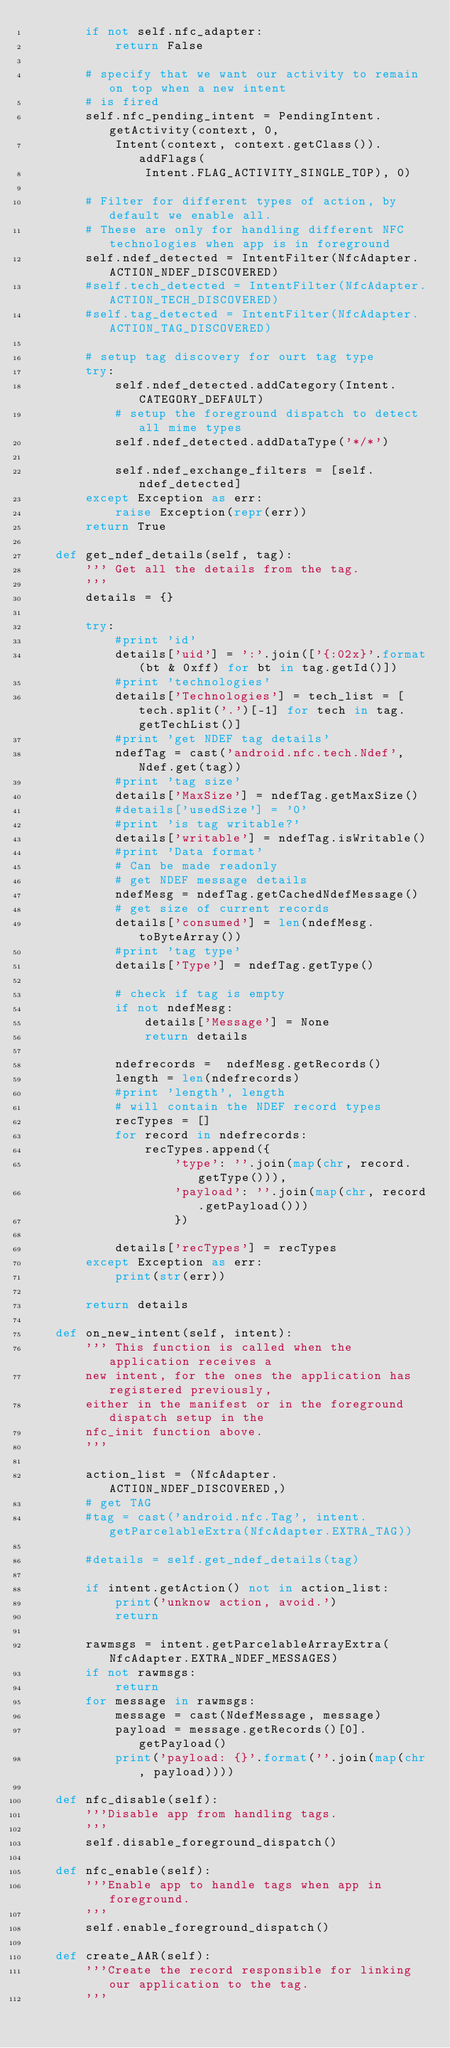<code> <loc_0><loc_0><loc_500><loc_500><_Python_>        if not self.nfc_adapter:
            return False
        
        # specify that we want our activity to remain on top when a new intent
        # is fired
        self.nfc_pending_intent = PendingIntent.getActivity(context, 0,
            Intent(context, context.getClass()).addFlags(
                Intent.FLAG_ACTIVITY_SINGLE_TOP), 0)

        # Filter for different types of action, by default we enable all.
        # These are only for handling different NFC technologies when app is in foreground
        self.ndef_detected = IntentFilter(NfcAdapter.ACTION_NDEF_DISCOVERED)
        #self.tech_detected = IntentFilter(NfcAdapter.ACTION_TECH_DISCOVERED)
        #self.tag_detected = IntentFilter(NfcAdapter.ACTION_TAG_DISCOVERED)

        # setup tag discovery for ourt tag type
        try:
            self.ndef_detected.addCategory(Intent.CATEGORY_DEFAULT)
            # setup the foreground dispatch to detect all mime types
            self.ndef_detected.addDataType('*/*')

            self.ndef_exchange_filters = [self.ndef_detected]
        except Exception as err:
            raise Exception(repr(err))
        return True

    def get_ndef_details(self, tag):
        ''' Get all the details from the tag.
        '''
        details = {}

        try:
            #print 'id'
            details['uid'] = ':'.join(['{:02x}'.format(bt & 0xff) for bt in tag.getId()])
            #print 'technologies'
            details['Technologies'] = tech_list = [tech.split('.')[-1] for tech in tag.getTechList()]
            #print 'get NDEF tag details'
            ndefTag = cast('android.nfc.tech.Ndef', Ndef.get(tag))
            #print 'tag size'
            details['MaxSize'] = ndefTag.getMaxSize()
            #details['usedSize'] = '0'
            #print 'is tag writable?'
            details['writable'] = ndefTag.isWritable()
            #print 'Data format'
            # Can be made readonly
            # get NDEF message details
            ndefMesg = ndefTag.getCachedNdefMessage()
            # get size of current records
            details['consumed'] = len(ndefMesg.toByteArray())
            #print 'tag type'
            details['Type'] = ndefTag.getType()

            # check if tag is empty
            if not ndefMesg:
                details['Message'] = None
                return details

            ndefrecords =  ndefMesg.getRecords()
            length = len(ndefrecords)
            #print 'length', length
            # will contain the NDEF record types
            recTypes = []
            for record in ndefrecords:
                recTypes.append({
                    'type': ''.join(map(chr, record.getType())),
                    'payload': ''.join(map(chr, record.getPayload()))
                    })

            details['recTypes'] = recTypes
        except Exception as err:
            print(str(err))

        return details

    def on_new_intent(self, intent):
        ''' This function is called when the application receives a
        new intent, for the ones the application has registered previously,
        either in the manifest or in the foreground dispatch setup in the
        nfc_init function above. 
        '''

        action_list = (NfcAdapter.ACTION_NDEF_DISCOVERED,)
        # get TAG
        #tag = cast('android.nfc.Tag', intent.getParcelableExtra(NfcAdapter.EXTRA_TAG))

        #details = self.get_ndef_details(tag)

        if intent.getAction() not in action_list:
            print('unknow action, avoid.')
            return

        rawmsgs = intent.getParcelableArrayExtra(NfcAdapter.EXTRA_NDEF_MESSAGES)
        if not rawmsgs:
            return
        for message in rawmsgs:
            message = cast(NdefMessage, message)
            payload = message.getRecords()[0].getPayload()
            print('payload: {}'.format(''.join(map(chr, payload))))

    def nfc_disable(self):
        '''Disable app from handling tags.
        '''
        self.disable_foreground_dispatch()

    def nfc_enable(self):
        '''Enable app to handle tags when app in foreground.
        '''
        self.enable_foreground_dispatch()

    def create_AAR(self):
        '''Create the record responsible for linking our application to the tag.
        '''</code> 